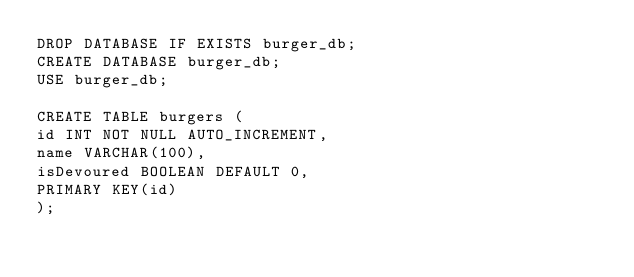Convert code to text. <code><loc_0><loc_0><loc_500><loc_500><_SQL_>DROP DATABASE IF EXISTS burger_db;
CREATE DATABASE burger_db;
USE burger_db;

CREATE TABLE burgers (
id INT NOT NULL AUTO_INCREMENT,
name VARCHAR(100),
isDevoured BOOLEAN DEFAULT 0,
PRIMARY KEY(id)
);</code> 